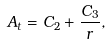<formula> <loc_0><loc_0><loc_500><loc_500>A _ { t } = C _ { 2 } + \frac { C _ { 3 } } { r } ,</formula> 